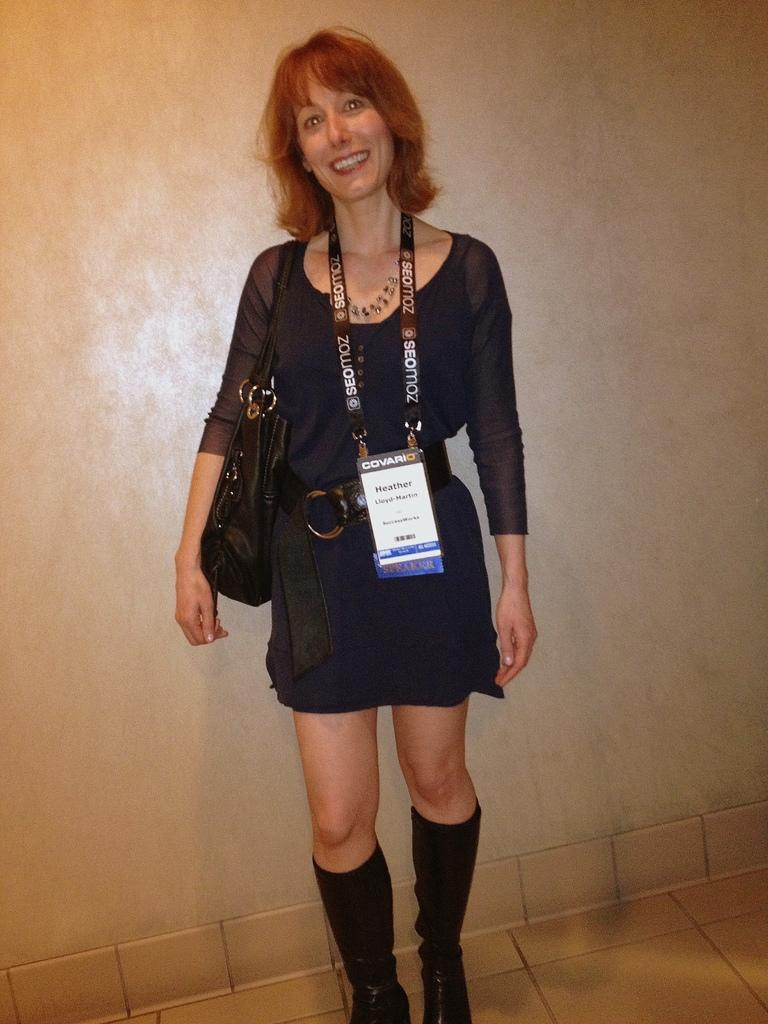Who is the main subject in the image? There is a lady in the image. What is the lady doing in the image? The lady is standing in the image. What is the lady wearing in the image? The lady is wearing a bag and an id card in the image. What is the lady's facial expression in the image? The lady is smiling in the image. Can you see any wounds on the lady in the image? There is no mention of any wounds on the lady in the image, so we cannot determine if any are present. 